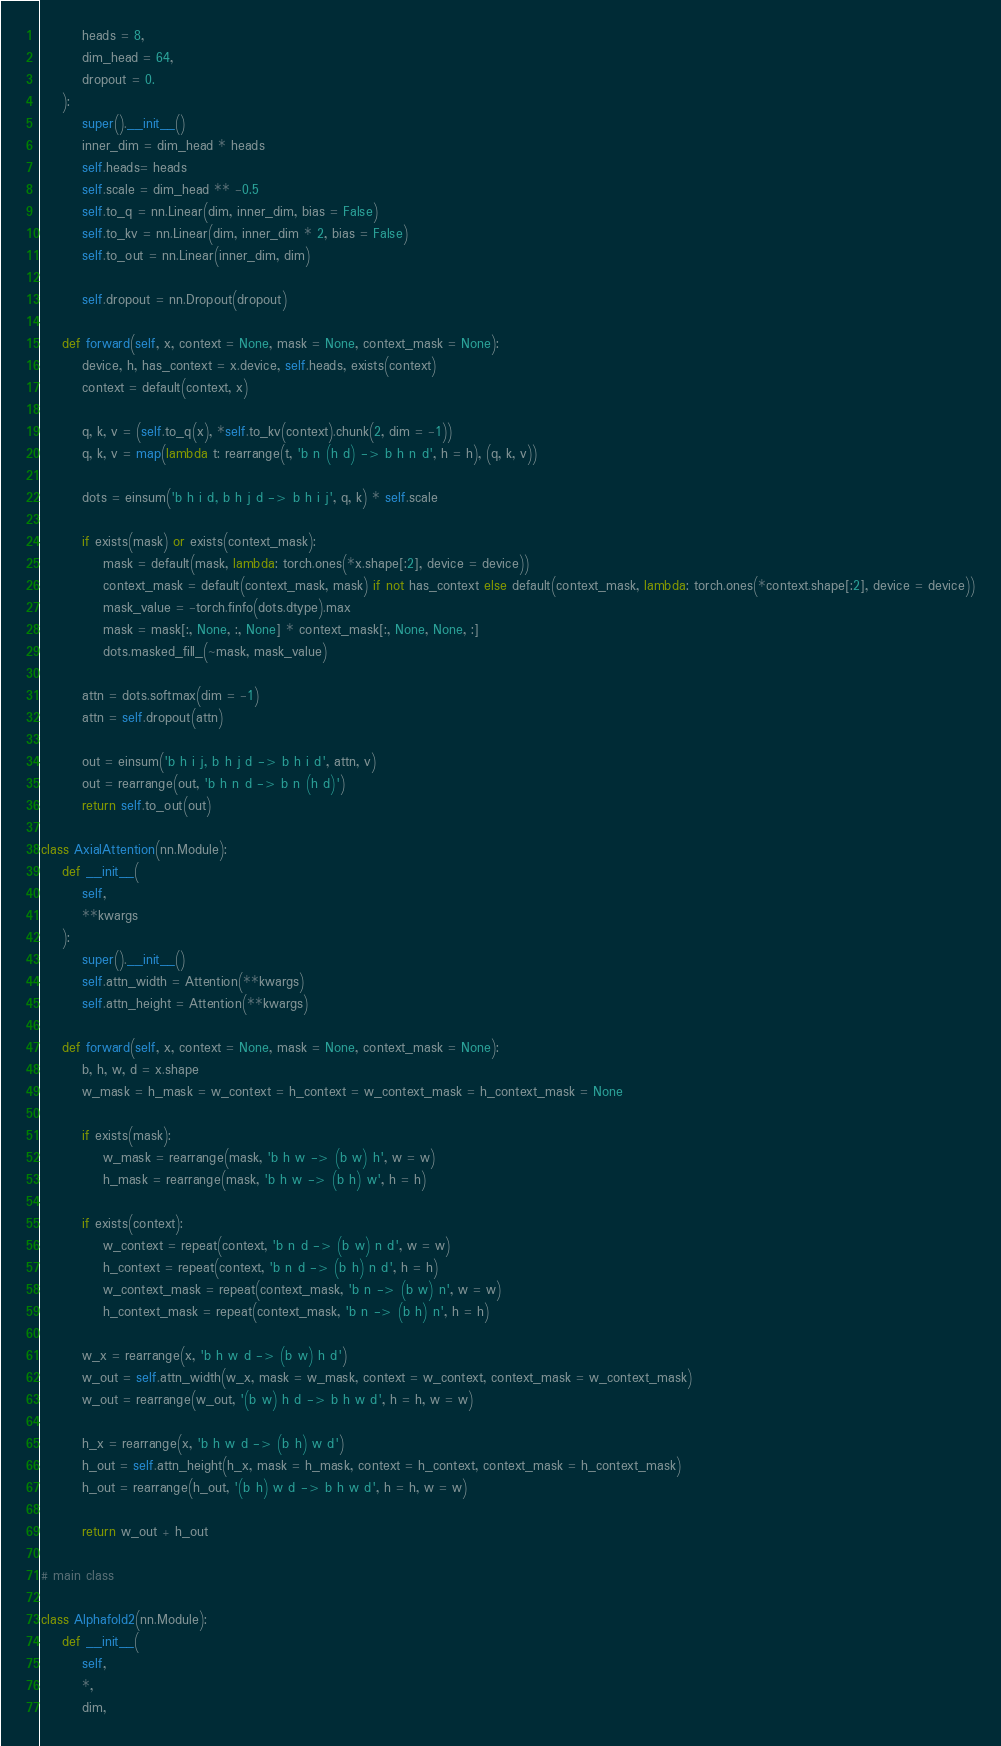Convert code to text. <code><loc_0><loc_0><loc_500><loc_500><_Python_>        heads = 8,
        dim_head = 64,
        dropout = 0.
    ):
        super().__init__()
        inner_dim = dim_head * heads
        self.heads= heads
        self.scale = dim_head ** -0.5
        self.to_q = nn.Linear(dim, inner_dim, bias = False)
        self.to_kv = nn.Linear(dim, inner_dim * 2, bias = False)
        self.to_out = nn.Linear(inner_dim, dim)

        self.dropout = nn.Dropout(dropout)

    def forward(self, x, context = None, mask = None, context_mask = None):
        device, h, has_context = x.device, self.heads, exists(context)
        context = default(context, x)

        q, k, v = (self.to_q(x), *self.to_kv(context).chunk(2, dim = -1))
        q, k, v = map(lambda t: rearrange(t, 'b n (h d) -> b h n d', h = h), (q, k, v))

        dots = einsum('b h i d, b h j d -> b h i j', q, k) * self.scale

        if exists(mask) or exists(context_mask):
            mask = default(mask, lambda: torch.ones(*x.shape[:2], device = device))
            context_mask = default(context_mask, mask) if not has_context else default(context_mask, lambda: torch.ones(*context.shape[:2], device = device))
            mask_value = -torch.finfo(dots.dtype).max
            mask = mask[:, None, :, None] * context_mask[:, None, None, :]
            dots.masked_fill_(~mask, mask_value)

        attn = dots.softmax(dim = -1)
        attn = self.dropout(attn)

        out = einsum('b h i j, b h j d -> b h i d', attn, v)
        out = rearrange(out, 'b h n d -> b n (h d)')
        return self.to_out(out)

class AxialAttention(nn.Module):
    def __init__(
        self,
        **kwargs
    ):
        super().__init__()
        self.attn_width = Attention(**kwargs)
        self.attn_height = Attention(**kwargs)

    def forward(self, x, context = None, mask = None, context_mask = None):
        b, h, w, d = x.shape
        w_mask = h_mask = w_context = h_context = w_context_mask = h_context_mask = None

        if exists(mask):
            w_mask = rearrange(mask, 'b h w -> (b w) h', w = w)
            h_mask = rearrange(mask, 'b h w -> (b h) w', h = h)

        if exists(context):
            w_context = repeat(context, 'b n d -> (b w) n d', w = w)
            h_context = repeat(context, 'b n d -> (b h) n d', h = h)
            w_context_mask = repeat(context_mask, 'b n -> (b w) n', w = w)
            h_context_mask = repeat(context_mask, 'b n -> (b h) n', h = h)

        w_x = rearrange(x, 'b h w d -> (b w) h d')
        w_out = self.attn_width(w_x, mask = w_mask, context = w_context, context_mask = w_context_mask)
        w_out = rearrange(w_out, '(b w) h d -> b h w d', h = h, w = w)

        h_x = rearrange(x, 'b h w d -> (b h) w d')
        h_out = self.attn_height(h_x, mask = h_mask, context = h_context, context_mask = h_context_mask)
        h_out = rearrange(h_out, '(b h) w d -> b h w d', h = h, w = w)

        return w_out + h_out

# main class

class Alphafold2(nn.Module):
    def __init__(
        self,
        *,
        dim,</code> 